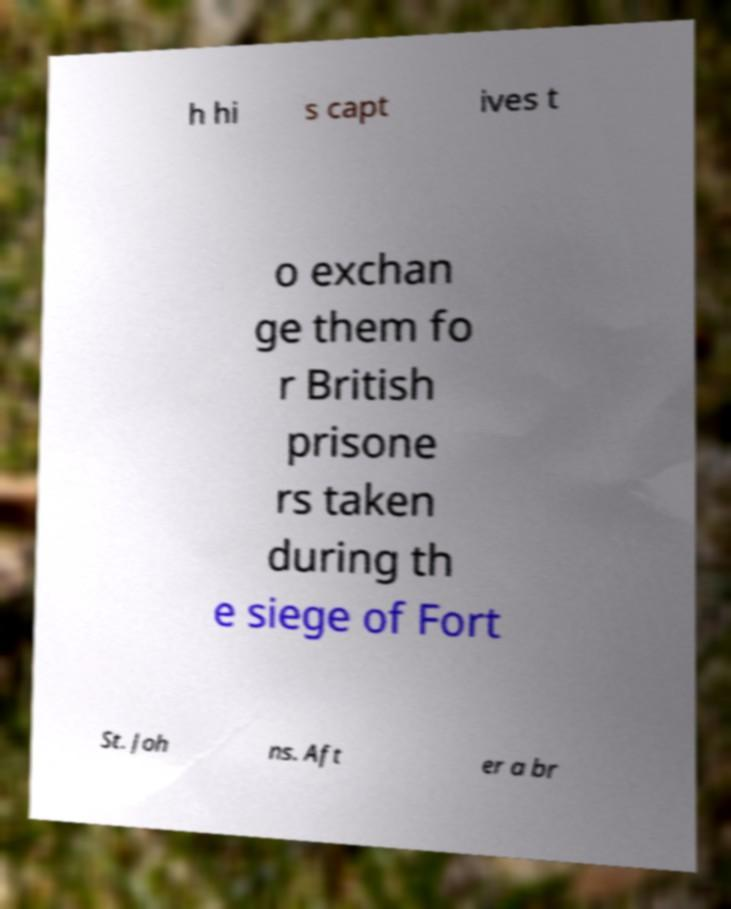For documentation purposes, I need the text within this image transcribed. Could you provide that? h hi s capt ives t o exchan ge them fo r British prisone rs taken during th e siege of Fort St. Joh ns. Aft er a br 